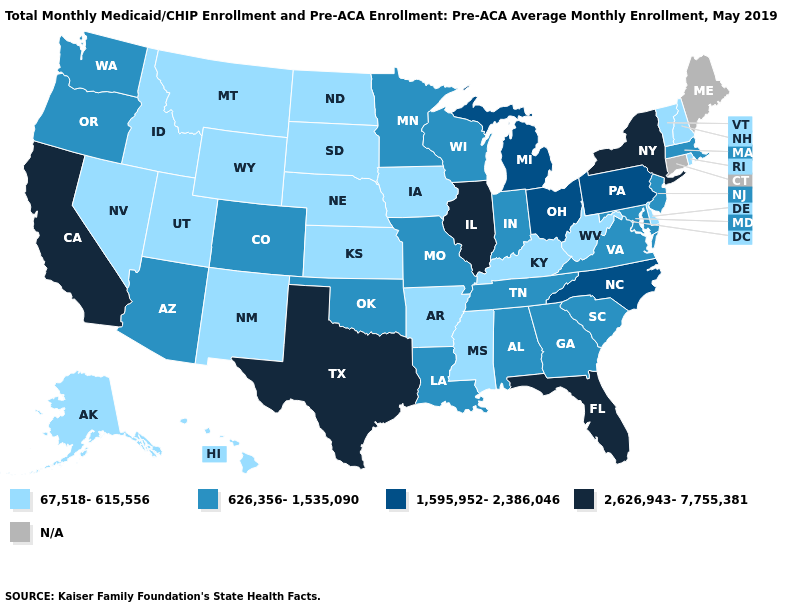Does Texas have the highest value in the South?
Write a very short answer. Yes. Does the map have missing data?
Give a very brief answer. Yes. Name the states that have a value in the range 2,626,943-7,755,381?
Concise answer only. California, Florida, Illinois, New York, Texas. What is the value of Connecticut?
Concise answer only. N/A. What is the value of Iowa?
Give a very brief answer. 67,518-615,556. Name the states that have a value in the range 2,626,943-7,755,381?
Short answer required. California, Florida, Illinois, New York, Texas. Is the legend a continuous bar?
Concise answer only. No. What is the value of Arkansas?
Keep it brief. 67,518-615,556. What is the highest value in the USA?
Concise answer only. 2,626,943-7,755,381. What is the value of Texas?
Answer briefly. 2,626,943-7,755,381. What is the value of Nebraska?
Keep it brief. 67,518-615,556. Among the states that border Tennessee , which have the lowest value?
Quick response, please. Arkansas, Kentucky, Mississippi. Among the states that border Kentucky , does Tennessee have the lowest value?
Write a very short answer. No. What is the value of Colorado?
Quick response, please. 626,356-1,535,090. Which states have the highest value in the USA?
Write a very short answer. California, Florida, Illinois, New York, Texas. 